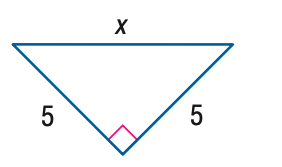Question: Find x.
Choices:
A. 5
B. 5 \sqrt { 2 }
C. 5 \sqrt { 3 }
D. 10
Answer with the letter. Answer: B 